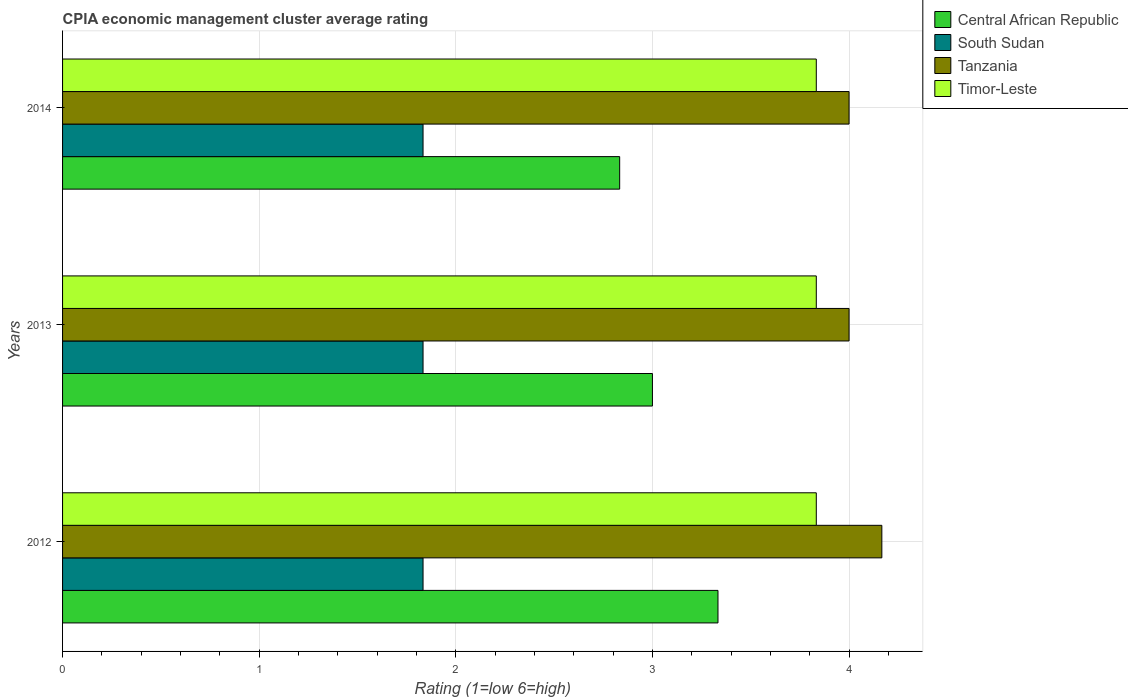How many groups of bars are there?
Your answer should be compact. 3. Are the number of bars on each tick of the Y-axis equal?
Provide a succinct answer. Yes. How many bars are there on the 3rd tick from the top?
Provide a short and direct response. 4. What is the label of the 2nd group of bars from the top?
Keep it short and to the point. 2013. What is the CPIA rating in South Sudan in 2014?
Your answer should be very brief. 1.83. Across all years, what is the maximum CPIA rating in Central African Republic?
Keep it short and to the point. 3.33. In which year was the CPIA rating in Timor-Leste maximum?
Provide a short and direct response. 2012. What is the total CPIA rating in Tanzania in the graph?
Your answer should be very brief. 12.17. What is the difference between the CPIA rating in Tanzania in 2012 and that in 2014?
Keep it short and to the point. 0.17. What is the difference between the CPIA rating in Timor-Leste in 2014 and the CPIA rating in South Sudan in 2013?
Your answer should be very brief. 2. What is the average CPIA rating in Central African Republic per year?
Keep it short and to the point. 3.06. In how many years, is the CPIA rating in Tanzania greater than 3 ?
Give a very brief answer. 3. What is the ratio of the CPIA rating in Central African Republic in 2013 to that in 2014?
Provide a succinct answer. 1.06. Is the CPIA rating in Tanzania in 2012 less than that in 2014?
Provide a succinct answer. No. Is the difference between the CPIA rating in Timor-Leste in 2013 and 2014 greater than the difference between the CPIA rating in Central African Republic in 2013 and 2014?
Your response must be concise. No. What is the difference between the highest and the lowest CPIA rating in South Sudan?
Your answer should be very brief. 3.3333333300245016e-6. Is it the case that in every year, the sum of the CPIA rating in South Sudan and CPIA rating in Tanzania is greater than the sum of CPIA rating in Timor-Leste and CPIA rating in Central African Republic?
Offer a terse response. No. What does the 3rd bar from the top in 2014 represents?
Your response must be concise. South Sudan. What does the 2nd bar from the bottom in 2014 represents?
Ensure brevity in your answer.  South Sudan. How many years are there in the graph?
Ensure brevity in your answer.  3. What is the difference between two consecutive major ticks on the X-axis?
Ensure brevity in your answer.  1. Are the values on the major ticks of X-axis written in scientific E-notation?
Offer a terse response. No. Does the graph contain any zero values?
Provide a succinct answer. No. How are the legend labels stacked?
Your answer should be compact. Vertical. What is the title of the graph?
Give a very brief answer. CPIA economic management cluster average rating. Does "Low & middle income" appear as one of the legend labels in the graph?
Your answer should be very brief. No. What is the label or title of the X-axis?
Your response must be concise. Rating (1=low 6=high). What is the Rating (1=low 6=high) in Central African Republic in 2012?
Give a very brief answer. 3.33. What is the Rating (1=low 6=high) of South Sudan in 2012?
Offer a very short reply. 1.83. What is the Rating (1=low 6=high) in Tanzania in 2012?
Offer a terse response. 4.17. What is the Rating (1=low 6=high) in Timor-Leste in 2012?
Your response must be concise. 3.83. What is the Rating (1=low 6=high) of South Sudan in 2013?
Keep it short and to the point. 1.83. What is the Rating (1=low 6=high) in Tanzania in 2013?
Ensure brevity in your answer.  4. What is the Rating (1=low 6=high) of Timor-Leste in 2013?
Offer a very short reply. 3.83. What is the Rating (1=low 6=high) of Central African Republic in 2014?
Your answer should be compact. 2.83. What is the Rating (1=low 6=high) of South Sudan in 2014?
Your response must be concise. 1.83. What is the Rating (1=low 6=high) of Timor-Leste in 2014?
Offer a terse response. 3.83. Across all years, what is the maximum Rating (1=low 6=high) of Central African Republic?
Make the answer very short. 3.33. Across all years, what is the maximum Rating (1=low 6=high) of South Sudan?
Keep it short and to the point. 1.83. Across all years, what is the maximum Rating (1=low 6=high) in Tanzania?
Keep it short and to the point. 4.17. Across all years, what is the maximum Rating (1=low 6=high) of Timor-Leste?
Ensure brevity in your answer.  3.83. Across all years, what is the minimum Rating (1=low 6=high) in Central African Republic?
Your answer should be compact. 2.83. Across all years, what is the minimum Rating (1=low 6=high) in South Sudan?
Offer a terse response. 1.83. Across all years, what is the minimum Rating (1=low 6=high) of Tanzania?
Offer a very short reply. 4. Across all years, what is the minimum Rating (1=low 6=high) in Timor-Leste?
Offer a very short reply. 3.83. What is the total Rating (1=low 6=high) in Central African Republic in the graph?
Make the answer very short. 9.17. What is the total Rating (1=low 6=high) in South Sudan in the graph?
Offer a very short reply. 5.5. What is the total Rating (1=low 6=high) in Tanzania in the graph?
Make the answer very short. 12.17. What is the difference between the Rating (1=low 6=high) in Central African Republic in 2012 and that in 2013?
Keep it short and to the point. 0.33. What is the difference between the Rating (1=low 6=high) in South Sudan in 2012 and that in 2013?
Make the answer very short. 0. What is the difference between the Rating (1=low 6=high) of Timor-Leste in 2012 and that in 2013?
Your response must be concise. 0. What is the difference between the Rating (1=low 6=high) in Central African Republic in 2012 and that in 2014?
Provide a succinct answer. 0.5. What is the difference between the Rating (1=low 6=high) in South Sudan in 2012 and that in 2014?
Your answer should be very brief. 0. What is the difference between the Rating (1=low 6=high) in Tanzania in 2012 and that in 2014?
Offer a terse response. 0.17. What is the difference between the Rating (1=low 6=high) in Timor-Leste in 2012 and that in 2014?
Provide a succinct answer. 0. What is the difference between the Rating (1=low 6=high) of Central African Republic in 2013 and that in 2014?
Your answer should be compact. 0.17. What is the difference between the Rating (1=low 6=high) of South Sudan in 2013 and that in 2014?
Provide a succinct answer. 0. What is the difference between the Rating (1=low 6=high) in Central African Republic in 2012 and the Rating (1=low 6=high) in Tanzania in 2013?
Your response must be concise. -0.67. What is the difference between the Rating (1=low 6=high) of South Sudan in 2012 and the Rating (1=low 6=high) of Tanzania in 2013?
Offer a very short reply. -2.17. What is the difference between the Rating (1=low 6=high) in Tanzania in 2012 and the Rating (1=low 6=high) in Timor-Leste in 2013?
Give a very brief answer. 0.33. What is the difference between the Rating (1=low 6=high) of Central African Republic in 2012 and the Rating (1=low 6=high) of South Sudan in 2014?
Offer a very short reply. 1.5. What is the difference between the Rating (1=low 6=high) of South Sudan in 2012 and the Rating (1=low 6=high) of Tanzania in 2014?
Your answer should be very brief. -2.17. What is the difference between the Rating (1=low 6=high) in Tanzania in 2012 and the Rating (1=low 6=high) in Timor-Leste in 2014?
Provide a short and direct response. 0.33. What is the difference between the Rating (1=low 6=high) in Central African Republic in 2013 and the Rating (1=low 6=high) in South Sudan in 2014?
Give a very brief answer. 1.17. What is the difference between the Rating (1=low 6=high) of Central African Republic in 2013 and the Rating (1=low 6=high) of Timor-Leste in 2014?
Provide a succinct answer. -0.83. What is the difference between the Rating (1=low 6=high) of South Sudan in 2013 and the Rating (1=low 6=high) of Tanzania in 2014?
Your answer should be compact. -2.17. What is the difference between the Rating (1=low 6=high) in South Sudan in 2013 and the Rating (1=low 6=high) in Timor-Leste in 2014?
Keep it short and to the point. -2. What is the difference between the Rating (1=low 6=high) in Tanzania in 2013 and the Rating (1=low 6=high) in Timor-Leste in 2014?
Your response must be concise. 0.17. What is the average Rating (1=low 6=high) in Central African Republic per year?
Provide a short and direct response. 3.06. What is the average Rating (1=low 6=high) in South Sudan per year?
Ensure brevity in your answer.  1.83. What is the average Rating (1=low 6=high) in Tanzania per year?
Offer a terse response. 4.06. What is the average Rating (1=low 6=high) in Timor-Leste per year?
Your answer should be very brief. 3.83. In the year 2012, what is the difference between the Rating (1=low 6=high) in South Sudan and Rating (1=low 6=high) in Tanzania?
Offer a very short reply. -2.33. In the year 2013, what is the difference between the Rating (1=low 6=high) of Central African Republic and Rating (1=low 6=high) of South Sudan?
Ensure brevity in your answer.  1.17. In the year 2013, what is the difference between the Rating (1=low 6=high) in Central African Republic and Rating (1=low 6=high) in Timor-Leste?
Ensure brevity in your answer.  -0.83. In the year 2013, what is the difference between the Rating (1=low 6=high) in South Sudan and Rating (1=low 6=high) in Tanzania?
Give a very brief answer. -2.17. In the year 2013, what is the difference between the Rating (1=low 6=high) in South Sudan and Rating (1=low 6=high) in Timor-Leste?
Offer a terse response. -2. In the year 2014, what is the difference between the Rating (1=low 6=high) of Central African Republic and Rating (1=low 6=high) of Tanzania?
Ensure brevity in your answer.  -1.17. In the year 2014, what is the difference between the Rating (1=low 6=high) of Central African Republic and Rating (1=low 6=high) of Timor-Leste?
Provide a short and direct response. -1. In the year 2014, what is the difference between the Rating (1=low 6=high) in South Sudan and Rating (1=low 6=high) in Tanzania?
Ensure brevity in your answer.  -2.17. In the year 2014, what is the difference between the Rating (1=low 6=high) in South Sudan and Rating (1=low 6=high) in Timor-Leste?
Your answer should be compact. -2. What is the ratio of the Rating (1=low 6=high) in Central African Republic in 2012 to that in 2013?
Offer a very short reply. 1.11. What is the ratio of the Rating (1=low 6=high) in South Sudan in 2012 to that in 2013?
Ensure brevity in your answer.  1. What is the ratio of the Rating (1=low 6=high) of Tanzania in 2012 to that in 2013?
Ensure brevity in your answer.  1.04. What is the ratio of the Rating (1=low 6=high) in Timor-Leste in 2012 to that in 2013?
Give a very brief answer. 1. What is the ratio of the Rating (1=low 6=high) in Central African Republic in 2012 to that in 2014?
Ensure brevity in your answer.  1.18. What is the ratio of the Rating (1=low 6=high) in South Sudan in 2012 to that in 2014?
Offer a terse response. 1. What is the ratio of the Rating (1=low 6=high) of Tanzania in 2012 to that in 2014?
Your answer should be very brief. 1.04. What is the ratio of the Rating (1=low 6=high) of Timor-Leste in 2012 to that in 2014?
Keep it short and to the point. 1. What is the ratio of the Rating (1=low 6=high) in Central African Republic in 2013 to that in 2014?
Offer a very short reply. 1.06. What is the ratio of the Rating (1=low 6=high) in South Sudan in 2013 to that in 2014?
Your response must be concise. 1. What is the ratio of the Rating (1=low 6=high) in Timor-Leste in 2013 to that in 2014?
Your answer should be compact. 1. What is the difference between the highest and the second highest Rating (1=low 6=high) of Central African Republic?
Your answer should be compact. 0.33. What is the difference between the highest and the second highest Rating (1=low 6=high) of South Sudan?
Offer a terse response. 0. What is the difference between the highest and the second highest Rating (1=low 6=high) in Tanzania?
Your answer should be compact. 0.17. What is the difference between the highest and the second highest Rating (1=low 6=high) of Timor-Leste?
Offer a very short reply. 0. What is the difference between the highest and the lowest Rating (1=low 6=high) in Central African Republic?
Offer a very short reply. 0.5. What is the difference between the highest and the lowest Rating (1=low 6=high) of South Sudan?
Keep it short and to the point. 0. What is the difference between the highest and the lowest Rating (1=low 6=high) of Timor-Leste?
Offer a very short reply. 0. 